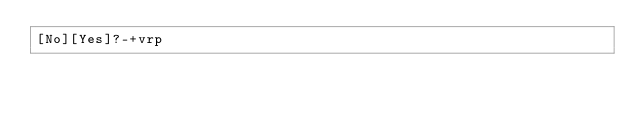<code> <loc_0><loc_0><loc_500><loc_500><_dc_>[No][Yes]?-+vrp</code> 